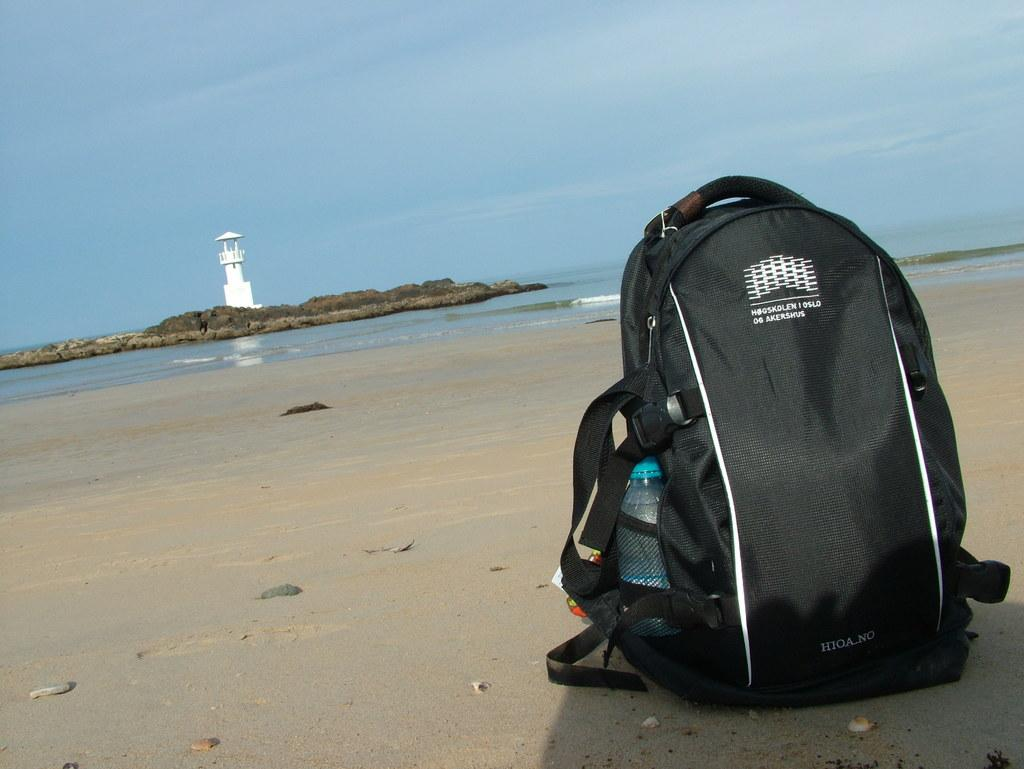Provide a one-sentence caption for the provided image. A HIOA NO backpack is sitting on a beach by a lighthouse. 